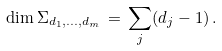<formula> <loc_0><loc_0><loc_500><loc_500>\dim \Sigma _ { d _ { 1 } , \dots , d _ { m } } \, = \, \sum _ { j } ( d _ { j } - 1 ) \, .</formula> 